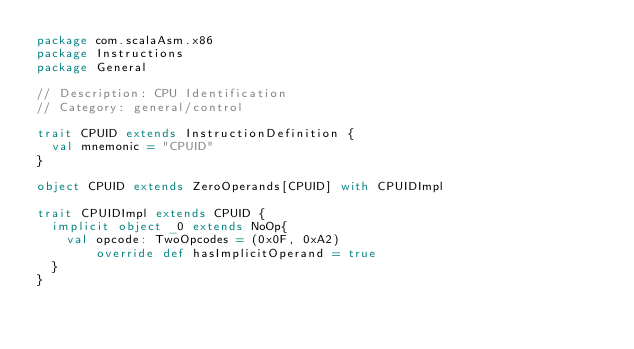Convert code to text. <code><loc_0><loc_0><loc_500><loc_500><_Scala_>package com.scalaAsm.x86
package Instructions
package General

// Description: CPU Identification
// Category: general/control

trait CPUID extends InstructionDefinition {
  val mnemonic = "CPUID"
}

object CPUID extends ZeroOperands[CPUID] with CPUIDImpl

trait CPUIDImpl extends CPUID {
  implicit object _0 extends NoOp{
    val opcode: TwoOpcodes = (0x0F, 0xA2)
        override def hasImplicitOperand = true
  }
}
</code> 